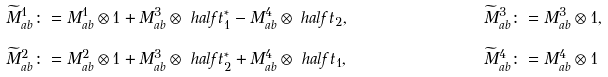Convert formula to latex. <formula><loc_0><loc_0><loc_500><loc_500>\widetilde { M } ^ { 1 } _ { a b } \colon & = M ^ { 1 } _ { a b } \otimes 1 + M ^ { 3 } _ { a b } \otimes \ h a l f t _ { 1 } ^ { * } - M ^ { 4 } _ { a b } \otimes \ h a l f t _ { 2 } , & \widetilde { M } ^ { 3 } _ { a b } \colon & = M ^ { 3 } _ { a b } \otimes 1 , \\ \widetilde { M } ^ { 2 } _ { a b } \colon & = M ^ { 2 } _ { a b } \otimes 1 + M ^ { 3 } _ { a b } \otimes \ h a l f t _ { 2 } ^ { * } + M ^ { 4 } _ { a b } \otimes \ h a l f t _ { 1 } , & \widetilde { M } ^ { 4 } _ { a b } \colon & = M ^ { 4 } _ { a b } \otimes 1</formula> 